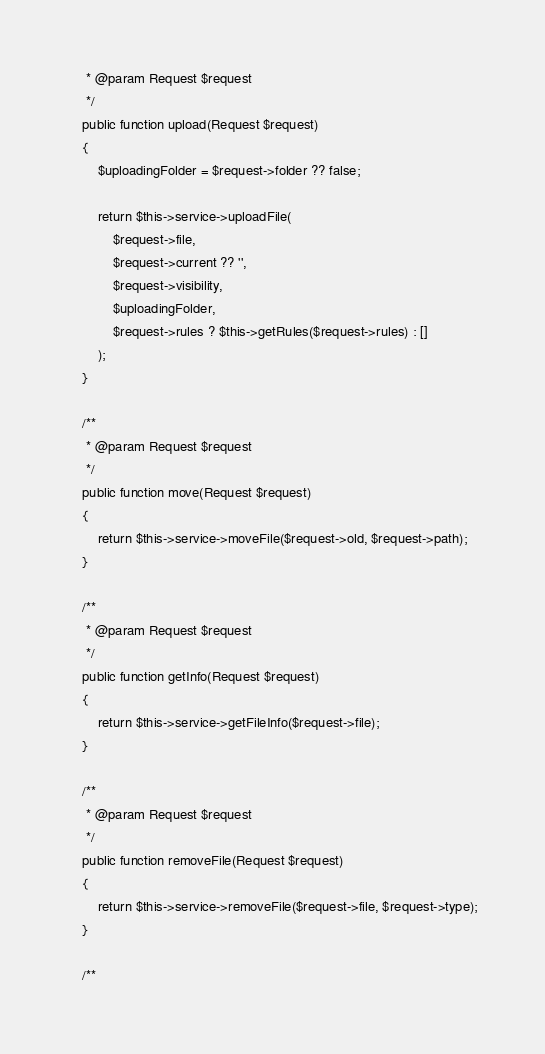<code> <loc_0><loc_0><loc_500><loc_500><_PHP_>     * @param Request $request
     */
    public function upload(Request $request)
    {
        $uploadingFolder = $request->folder ?? false;

        return $this->service->uploadFile(
            $request->file,
            $request->current ?? '',
            $request->visibility,
            $uploadingFolder,
            $request->rules ? $this->getRules($request->rules) : []
        );
    }

    /**
     * @param Request $request
     */
    public function move(Request $request)
    {
        return $this->service->moveFile($request->old, $request->path);
    }

    /**
     * @param Request $request
     */
    public function getInfo(Request $request)
    {
        return $this->service->getFileInfo($request->file);
    }

    /**
     * @param Request $request
     */
    public function removeFile(Request $request)
    {
        return $this->service->removeFile($request->file, $request->type);
    }

    /**</code> 